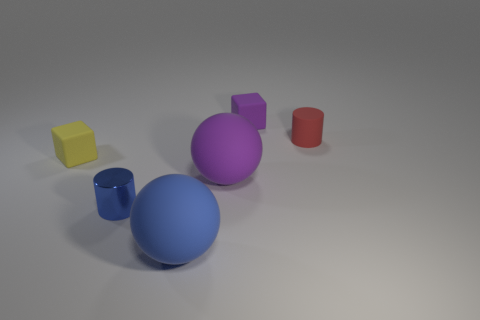Subtract all red blocks. Subtract all blue spheres. How many blocks are left? 2 Add 3 purple matte things. How many objects exist? 9 Subtract all cylinders. How many objects are left? 4 Add 1 tiny yellow things. How many tiny yellow things are left? 2 Add 3 yellow objects. How many yellow objects exist? 4 Subtract 1 yellow cubes. How many objects are left? 5 Subtract all small purple things. Subtract all large green objects. How many objects are left? 5 